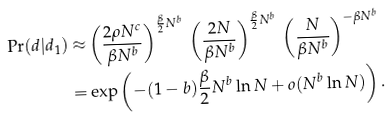Convert formula to latex. <formula><loc_0><loc_0><loc_500><loc_500>\Pr ( d | d _ { 1 } ) \approx & \left ( \frac { 2 \rho N ^ { c } } { \beta N ^ { b } } \right ) ^ { \frac { \beta } { 2 } N ^ { b } } \, \left ( \frac { 2 N } { \beta N ^ { b } } \right ) ^ { \frac { \beta } { 2 } N ^ { b } } \, \left ( \frac { N } { \beta N ^ { b } } \right ) ^ { - \beta N ^ { b } } \\ = & \exp \left ( - ( 1 - b ) \frac { \beta } { 2 } N ^ { b } \ln N + o ( N ^ { b } \ln N ) \right ) .</formula> 